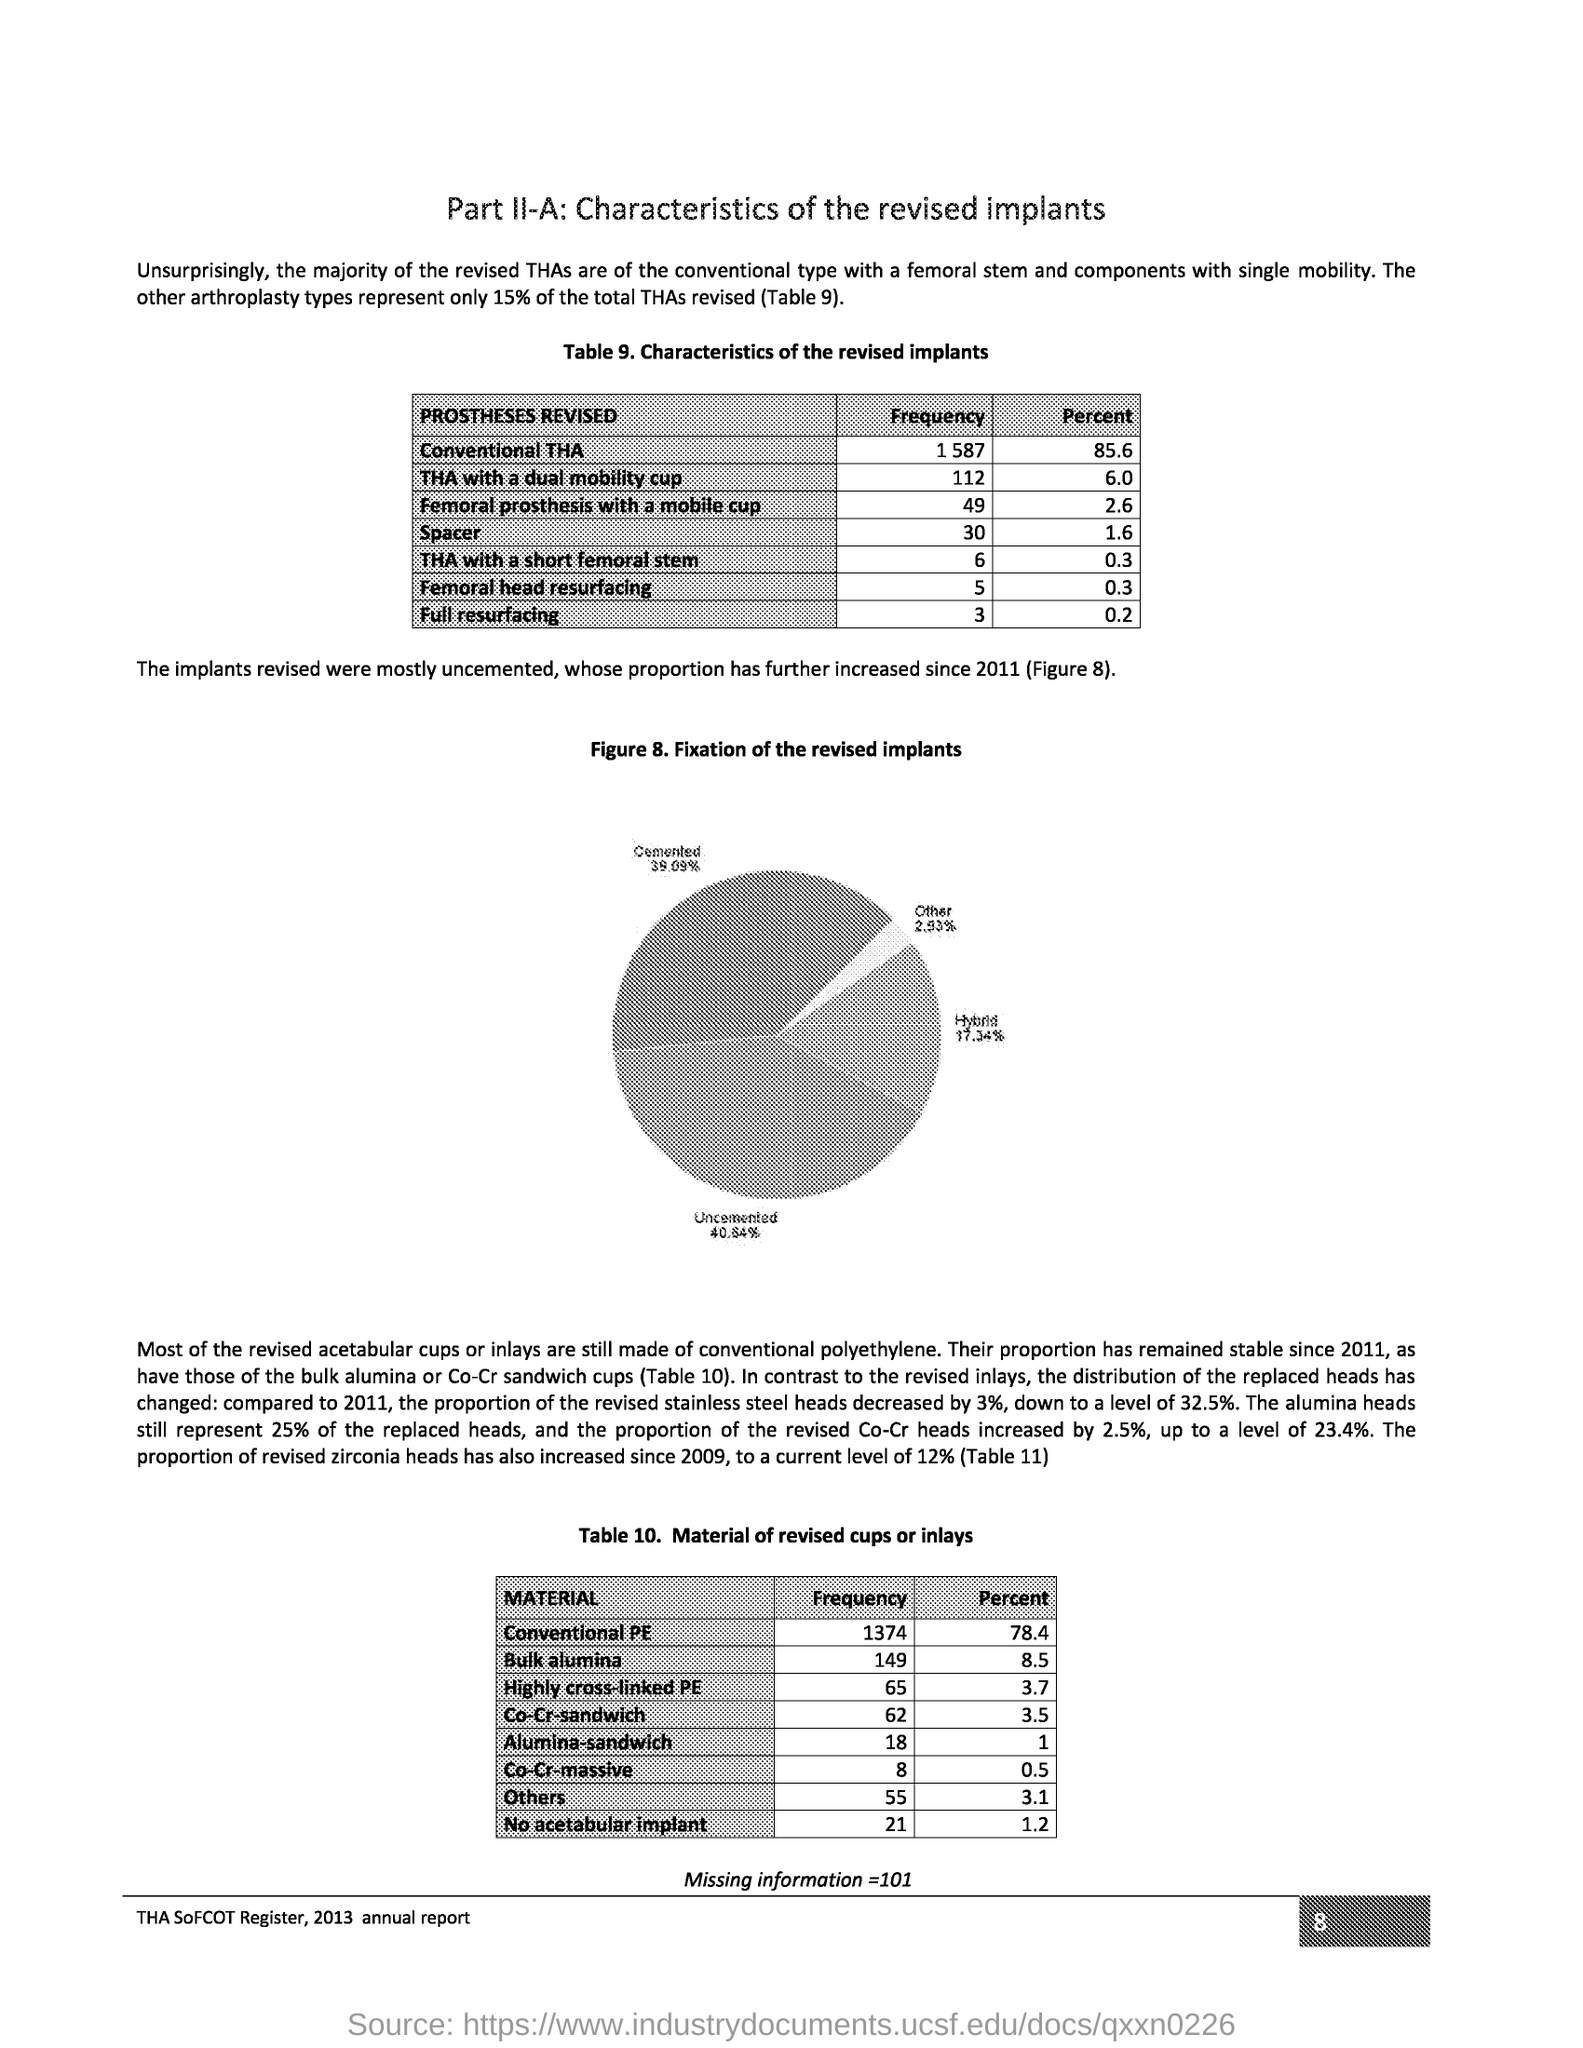What is the document title?
Your response must be concise. Part II-A: Characteristics of the revised implants. What is the title of the table 9?
Offer a terse response. Table 9. Characteristics of the revised implants. How much percentage does other arthroplasty types represent of the total THAs revised?
Offer a very short reply. 15% of the total THAs revised. What is the frequency of THA with a short femoral stem?
Keep it short and to the point. 6. What percent is Full resurfacing?
Your answer should be compact. 0.2. What is figure 8 title?
Provide a short and direct response. Figure 8. Fixation of the revised implants. In the pie chart in Figure 8, what percent is Cemented?
Your response must be concise. 39.09. From which report is the page taken?
Your answer should be compact. THA Sofcot register, 2013 annual report. What is the heading of table 10?
Your answer should be very brief. Table 10. Material of revised cups or inlays. What is the percent of No acetabular implant?
Provide a succinct answer. 1.2. 